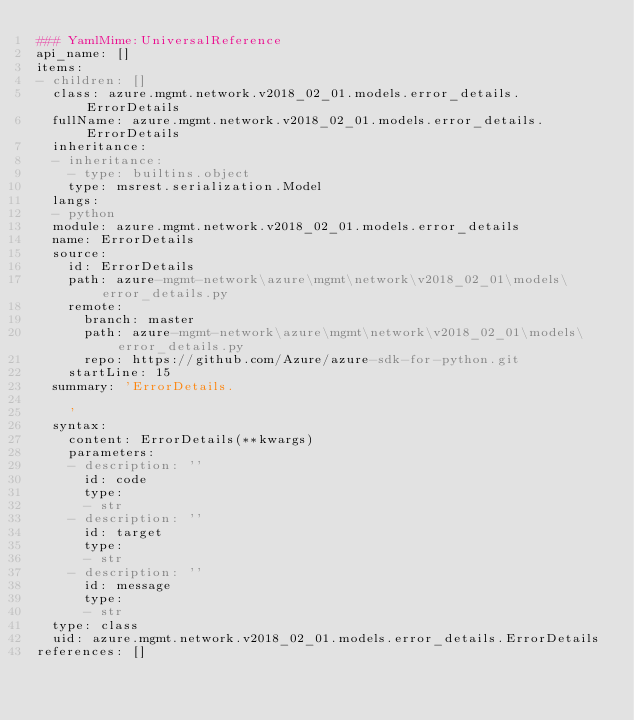Convert code to text. <code><loc_0><loc_0><loc_500><loc_500><_YAML_>### YamlMime:UniversalReference
api_name: []
items:
- children: []
  class: azure.mgmt.network.v2018_02_01.models.error_details.ErrorDetails
  fullName: azure.mgmt.network.v2018_02_01.models.error_details.ErrorDetails
  inheritance:
  - inheritance:
    - type: builtins.object
    type: msrest.serialization.Model
  langs:
  - python
  module: azure.mgmt.network.v2018_02_01.models.error_details
  name: ErrorDetails
  source:
    id: ErrorDetails
    path: azure-mgmt-network\azure\mgmt\network\v2018_02_01\models\error_details.py
    remote:
      branch: master
      path: azure-mgmt-network\azure\mgmt\network\v2018_02_01\models\error_details.py
      repo: https://github.com/Azure/azure-sdk-for-python.git
    startLine: 15
  summary: 'ErrorDetails.

    '
  syntax:
    content: ErrorDetails(**kwargs)
    parameters:
    - description: ''
      id: code
      type:
      - str
    - description: ''
      id: target
      type:
      - str
    - description: ''
      id: message
      type:
      - str
  type: class
  uid: azure.mgmt.network.v2018_02_01.models.error_details.ErrorDetails
references: []
</code> 